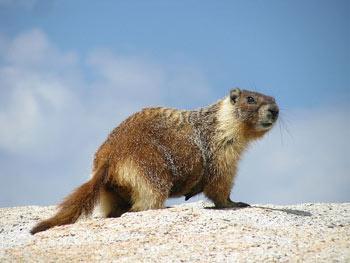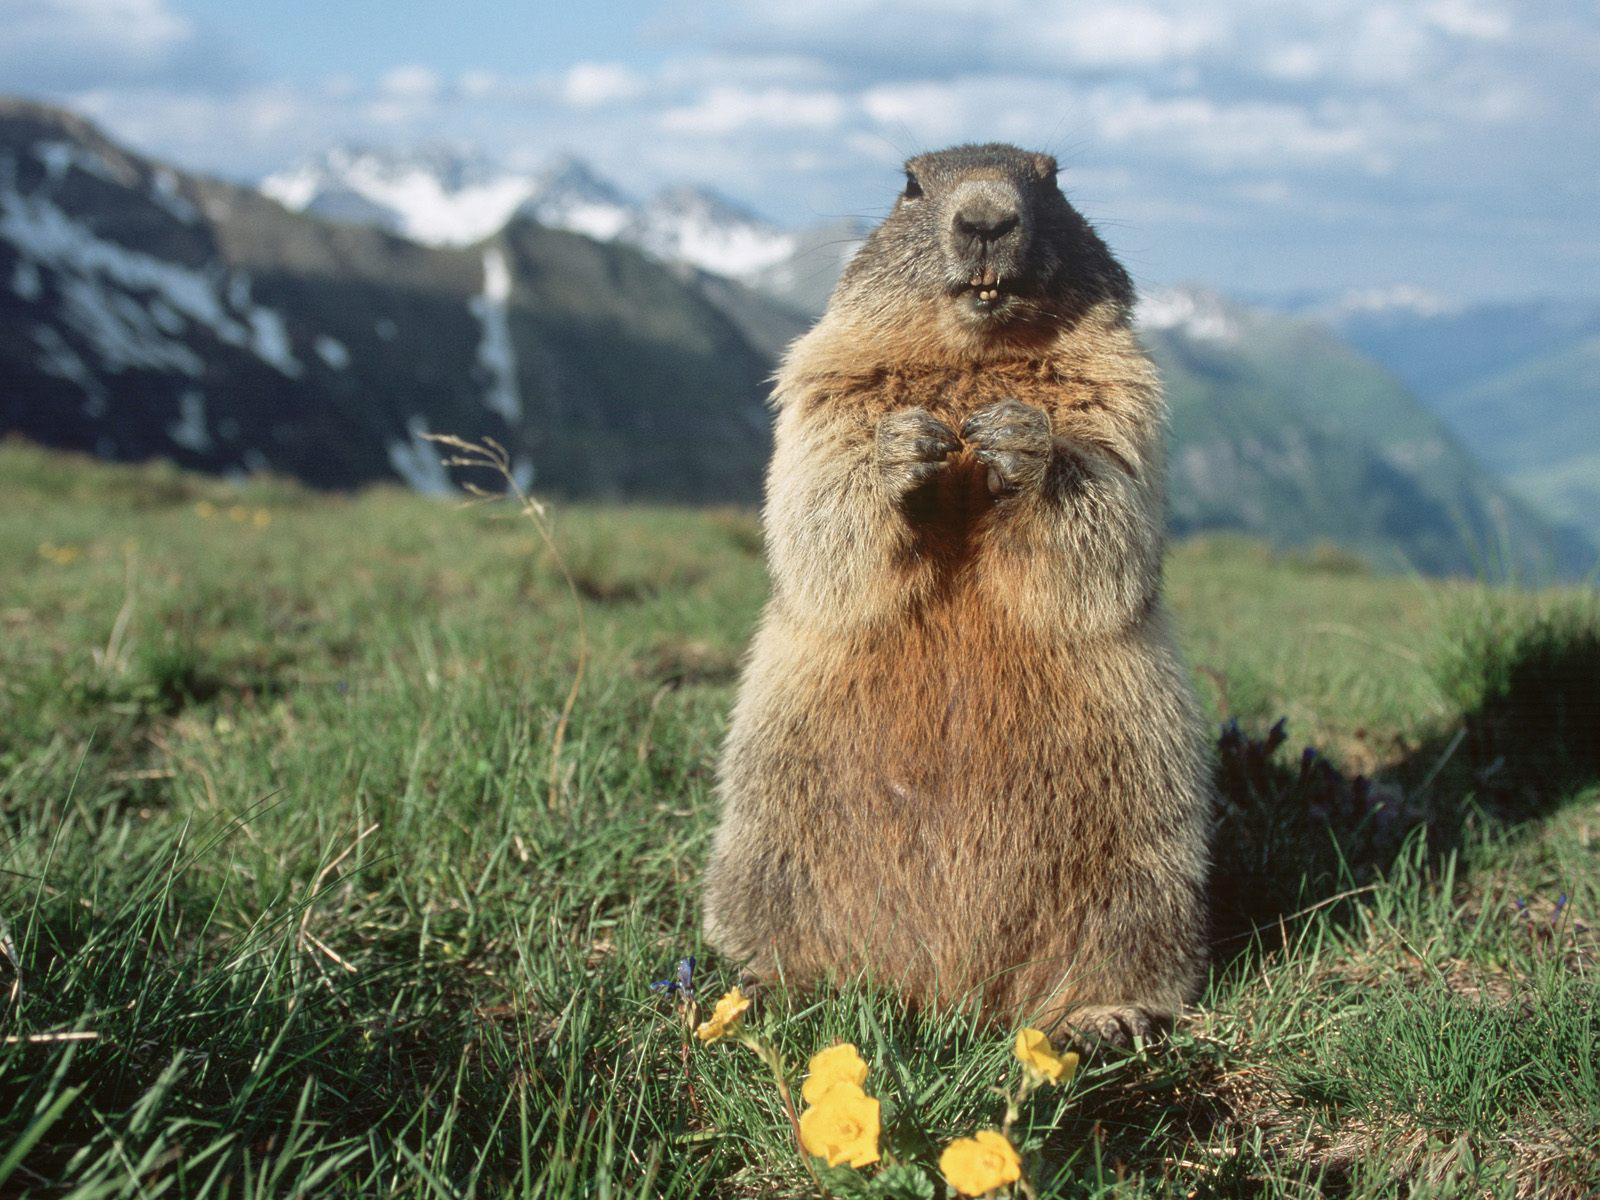The first image is the image on the left, the second image is the image on the right. Analyze the images presented: Is the assertion "the animal in the image on the left is facing right" valid? Answer yes or no. Yes. The first image is the image on the left, the second image is the image on the right. Given the left and right images, does the statement "Marmot in right image is standing up with arms dangling in front." hold true? Answer yes or no. No. 